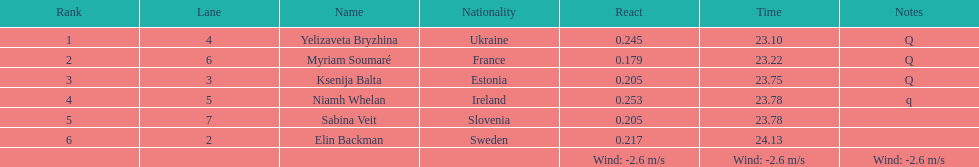The distinction between yelizaveta bryzhina's time and ksenija balta's time? 0.65. 